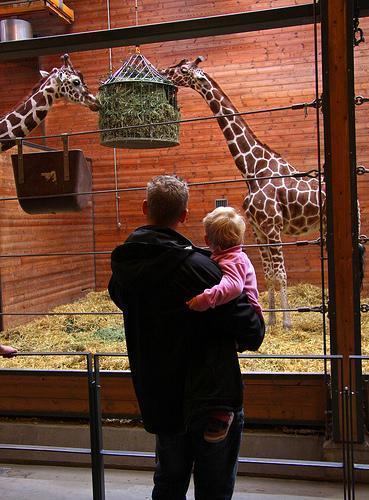How many people are there?
Give a very brief answer. 2. 